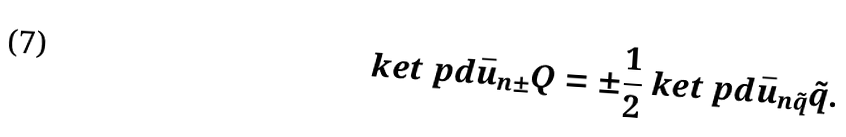Convert formula to latex. <formula><loc_0><loc_0><loc_500><loc_500>\ k e t { \ p d { \bar { u } _ { n \pm } } { Q } } = \pm \frac { 1 } { 2 } \ k e t { \ p d { \bar { u } _ { n \tilde { q } } } { \tilde { q } } } .</formula> 